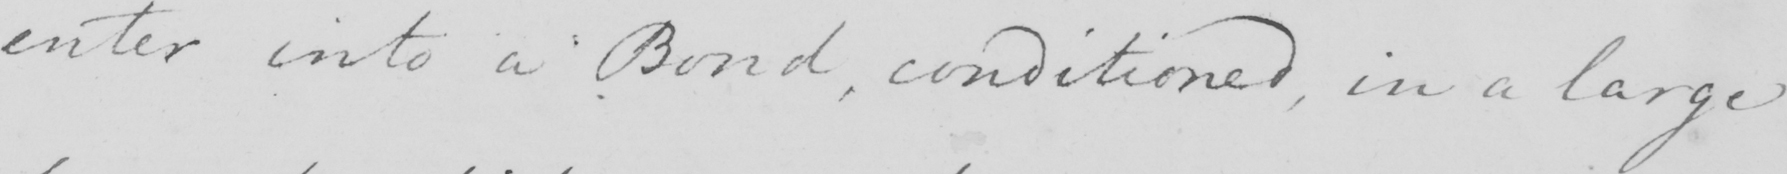Can you tell me what this handwritten text says? enter into a Bond , conditioned , in a large 